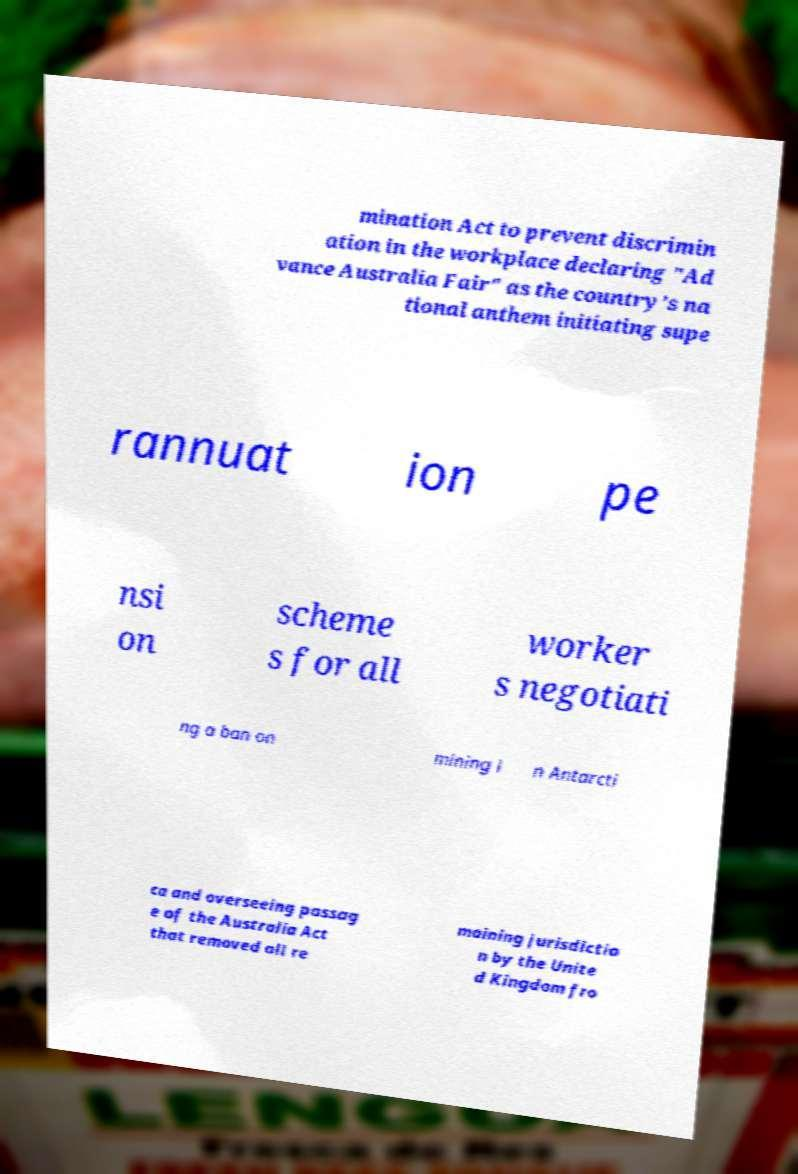What messages or text are displayed in this image? I need them in a readable, typed format. mination Act to prevent discrimin ation in the workplace declaring "Ad vance Australia Fair" as the country's na tional anthem initiating supe rannuat ion pe nsi on scheme s for all worker s negotiati ng a ban on mining i n Antarcti ca and overseeing passag e of the Australia Act that removed all re maining jurisdictio n by the Unite d Kingdom fro 